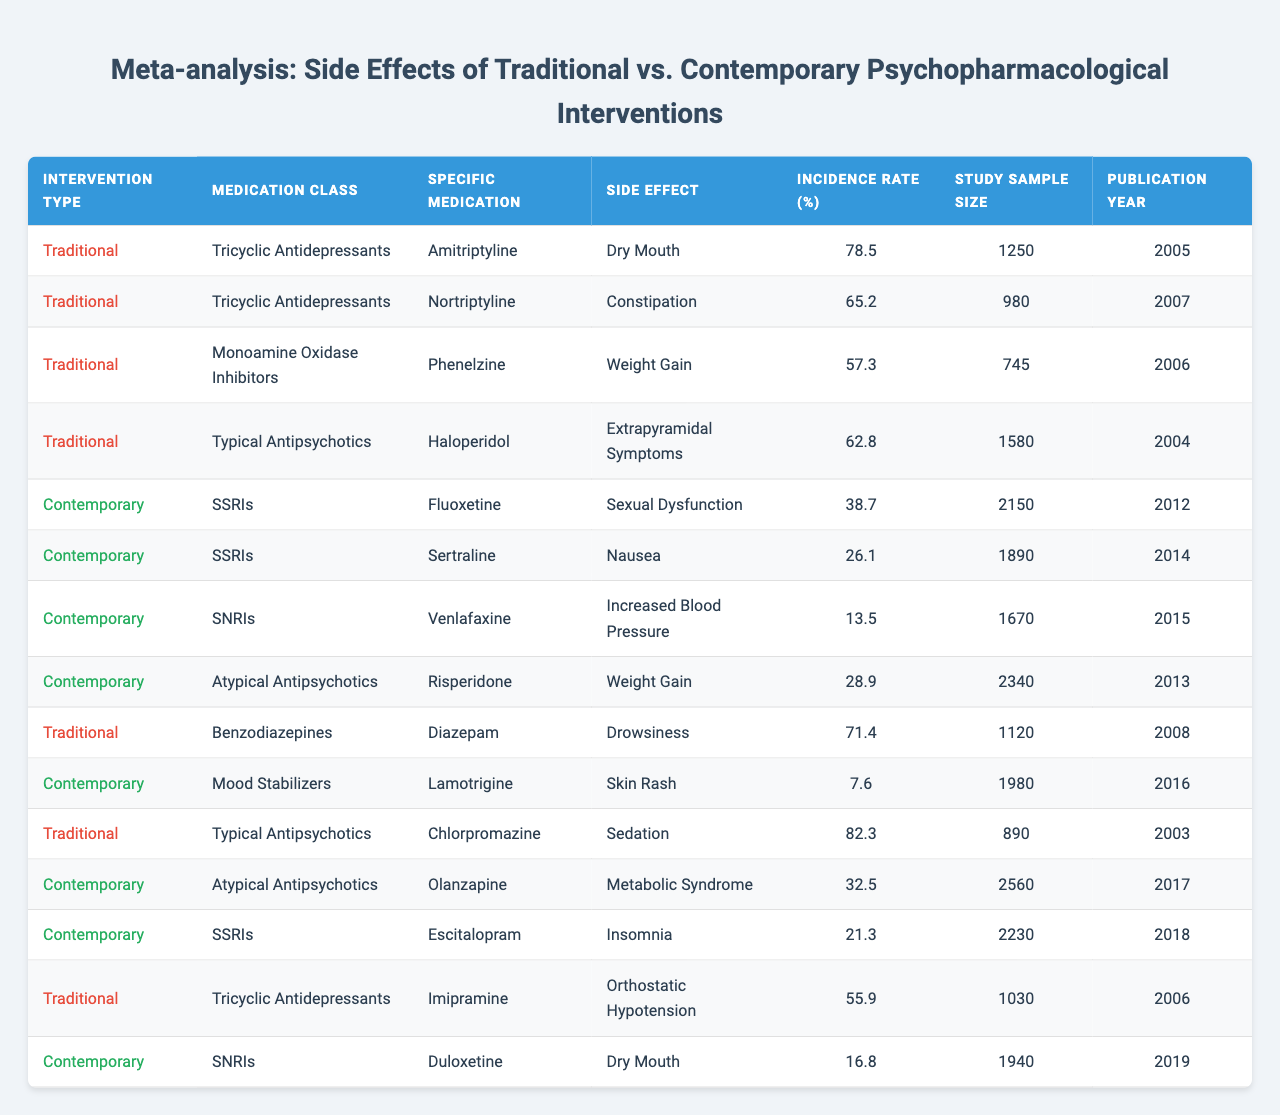What is the side effect with the highest incidence rate for traditional interventions? In the table, the side effects with their corresponding incidence rates for traditional interventions include: Dry Mouth (78.5%), Constipation (65.2%), Weight Gain (57.3%), Extrapyramidal Symptoms (62.8%), Drowsiness (71.4%), Sedation (82.3%), and Orthostatic Hypotension (55.9%). The highest incidence rate is for Sedation associated with Chlorpromazine at 82.3%.
Answer: Sedation (82.3%) Which contemporary medication has the lowest incidence of side effects? The table lists the side effects for contemporary medications: Sexual Dysfunction (38.7%), Nausea (26.1%), Increased Blood Pressure (13.5%), Weight Gain (28.9%), Skin Rash (7.6%), Insomnia (21.3%), and Dry Mouth (16.8%). The lowest incidence is for Skin Rash associated with Lamotrigine at 7.6%.
Answer: Skin Rash (7.6%) What is the average incidence rate of side effects for traditional medications? The incidence rates for traditional medications are: 78.5%, 65.2%, 57.3%, 62.8%, 71.4%, 82.3%, 55.9%. Adding them gives a total of 78.5 + 65.2 + 57.3 + 62.8 + 71.4 + 82.3 + 55.9 = 413.4. There are 7 traditional medications, so the average is 413.4/7 ≈ 59.06%.
Answer: 59.06% Is there any traditional medication associated with "Weight Gain"? The table shows two instances of weight gain: one for Phenelzine (57.3%) under traditional interventions and another for Olanzapine (32.5%) under contemporary interventions. Since the question specifies traditional medication, the answer is yes, associated with Phenelzine.
Answer: Yes Which type of intervention generally shows higher incidence rates for side effects, traditional or contemporary? By comparing the highest incidence rates, traditional interventions include Sedation (82.3%) and Dry Mouth (78.5%), while contemporary interventions have Sexual Dysfunction (38.7%) as the highest. This indicates that traditional interventions generally have higher incidence rates.
Answer: Traditional interventions How many unique specific medications are listed for contemporary interventions? The table lists the following contemporary specific medications: Fluoxetine, Sertraline, Venlafaxine, Risperidone, Lamotrigine, Olanzapine, and Duloxetine. Counting these gives a total of 7 unique medications.
Answer: 7 What is the side effect rate for Venlafaxine compared to the lowest in contemporary medications? Venlafaxine has an incidence rate of 13.5%. The lowest incidence in contemporary medications is Skin Rash at 7.6%. 13.5% - 7.6% = 5.9%, indicating that Venlafaxine's incidence rate is 5.9% higher.
Answer: 5.9% higher Is there a traditional medication that causes "Dry Mouth"? The table indicates that Amitriptyline has a side effect of Dry Mouth with an incidence rate of 78.5%. Therefore, the answer is yes, there is a traditional medication that causes Dry Mouth.
Answer: Yes 